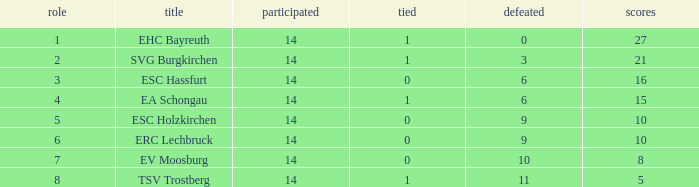Can you parse all the data within this table? {'header': ['role', 'title', 'participated', 'tied', 'defeated', 'scores'], 'rows': [['1', 'EHC Bayreuth', '14', '1', '0', '27'], ['2', 'SVG Burgkirchen', '14', '1', '3', '21'], ['3', 'ESC Hassfurt', '14', '0', '6', '16'], ['4', 'EA Schongau', '14', '1', '6', '15'], ['5', 'ESC Holzkirchen', '14', '0', '9', '10'], ['6', 'ERC Lechbruck', '14', '0', '9', '10'], ['7', 'EV Moosburg', '14', '0', '10', '8'], ['8', 'TSV Trostberg', '14', '1', '11', '5']]} What's the points that has a lost more 6, played less than 14 and a position more than 1? None. 